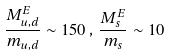<formula> <loc_0><loc_0><loc_500><loc_500>\frac { M _ { u , d } ^ { E } } { m _ { u , d } } \sim 1 5 0 \, , \, \frac { M _ { s } ^ { E } } { m _ { s } } \sim 1 0</formula> 